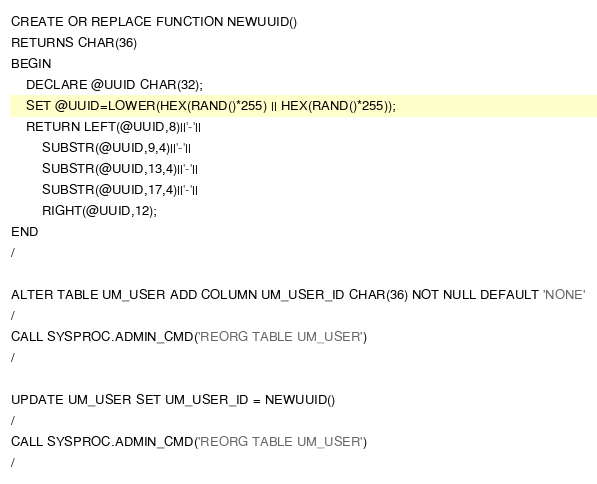Convert code to text. <code><loc_0><loc_0><loc_500><loc_500><_SQL_>CREATE OR REPLACE FUNCTION NEWUUID()
RETURNS CHAR(36)
BEGIN
    DECLARE @UUID CHAR(32);
    SET @UUID=LOWER(HEX(RAND()*255) || HEX(RAND()*255));
    RETURN LEFT(@UUID,8)||'-'||
        SUBSTR(@UUID,9,4)||'-'||
        SUBSTR(@UUID,13,4)||'-'||
        SUBSTR(@UUID,17,4)||'-'||
        RIGHT(@UUID,12);
END
/

ALTER TABLE UM_USER ADD COLUMN UM_USER_ID CHAR(36) NOT NULL DEFAULT 'NONE'
/
CALL SYSPROC.ADMIN_CMD('REORG TABLE UM_USER')
/

UPDATE UM_USER SET UM_USER_ID = NEWUUID()
/
CALL SYSPROC.ADMIN_CMD('REORG TABLE UM_USER')
/
</code> 